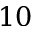<formula> <loc_0><loc_0><loc_500><loc_500>1 0</formula> 